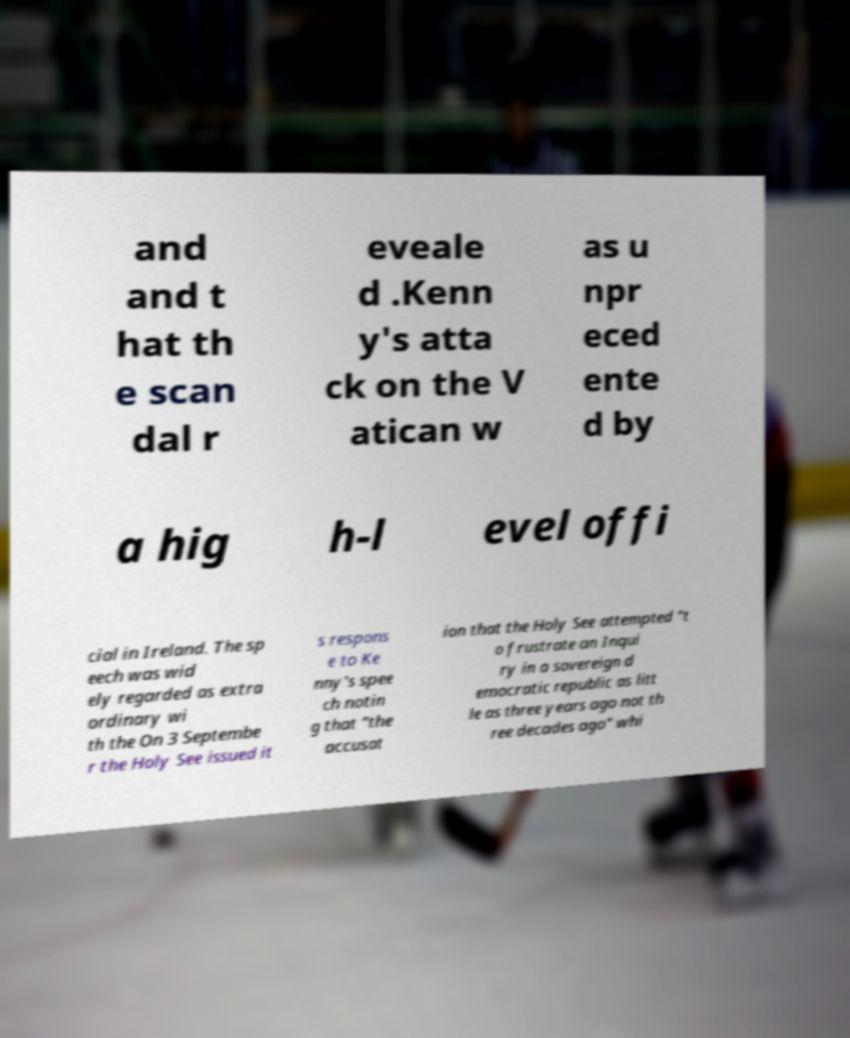Can you read and provide the text displayed in the image?This photo seems to have some interesting text. Can you extract and type it out for me? and and t hat th e scan dal r eveale d .Kenn y's atta ck on the V atican w as u npr eced ente d by a hig h-l evel offi cial in Ireland. The sp eech was wid ely regarded as extra ordinary wi th the On 3 Septembe r the Holy See issued it s respons e to Ke nny's spee ch notin g that "the accusat ion that the Holy See attempted "t o frustrate an Inqui ry in a sovereign d emocratic republic as litt le as three years ago not th ree decades ago" whi 